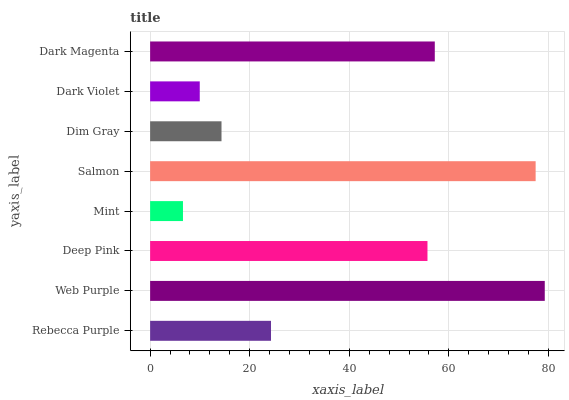Is Mint the minimum?
Answer yes or no. Yes. Is Web Purple the maximum?
Answer yes or no. Yes. Is Deep Pink the minimum?
Answer yes or no. No. Is Deep Pink the maximum?
Answer yes or no. No. Is Web Purple greater than Deep Pink?
Answer yes or no. Yes. Is Deep Pink less than Web Purple?
Answer yes or no. Yes. Is Deep Pink greater than Web Purple?
Answer yes or no. No. Is Web Purple less than Deep Pink?
Answer yes or no. No. Is Deep Pink the high median?
Answer yes or no. Yes. Is Rebecca Purple the low median?
Answer yes or no. Yes. Is Web Purple the high median?
Answer yes or no. No. Is Dark Violet the low median?
Answer yes or no. No. 